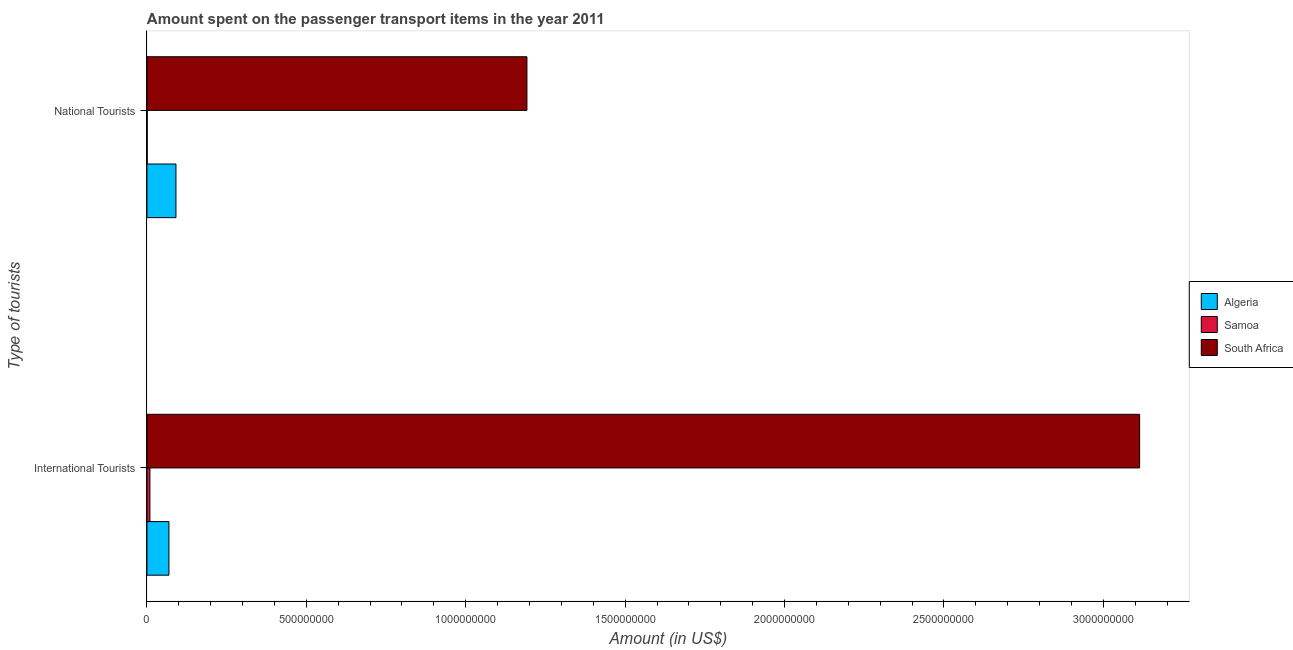How many groups of bars are there?
Your answer should be very brief. 2. How many bars are there on the 2nd tick from the top?
Give a very brief answer. 3. How many bars are there on the 2nd tick from the bottom?
Your answer should be very brief. 3. What is the label of the 2nd group of bars from the top?
Make the answer very short. International Tourists. What is the amount spent on transport items of international tourists in Algeria?
Give a very brief answer. 6.90e+07. Across all countries, what is the maximum amount spent on transport items of international tourists?
Provide a short and direct response. 3.11e+09. Across all countries, what is the minimum amount spent on transport items of national tourists?
Offer a terse response. 9.00e+05. In which country was the amount spent on transport items of international tourists maximum?
Offer a terse response. South Africa. In which country was the amount spent on transport items of national tourists minimum?
Your answer should be very brief. Samoa. What is the total amount spent on transport items of national tourists in the graph?
Your response must be concise. 1.28e+09. What is the difference between the amount spent on transport items of national tourists in South Africa and that in Samoa?
Your response must be concise. 1.19e+09. What is the difference between the amount spent on transport items of national tourists in Samoa and the amount spent on transport items of international tourists in Algeria?
Keep it short and to the point. -6.81e+07. What is the average amount spent on transport items of international tourists per country?
Make the answer very short. 1.06e+09. What is the difference between the amount spent on transport items of national tourists and amount spent on transport items of international tourists in Samoa?
Your answer should be compact. -8.40e+06. What is the ratio of the amount spent on transport items of national tourists in Samoa to that in South Africa?
Your response must be concise. 0. In how many countries, is the amount spent on transport items of international tourists greater than the average amount spent on transport items of international tourists taken over all countries?
Give a very brief answer. 1. What does the 1st bar from the top in International Tourists represents?
Offer a terse response. South Africa. What does the 3rd bar from the bottom in National Tourists represents?
Provide a succinct answer. South Africa. How many countries are there in the graph?
Your response must be concise. 3. What is the difference between two consecutive major ticks on the X-axis?
Offer a very short reply. 5.00e+08. Does the graph contain any zero values?
Provide a short and direct response. No. How many legend labels are there?
Give a very brief answer. 3. What is the title of the graph?
Your response must be concise. Amount spent on the passenger transport items in the year 2011. Does "Congo (Democratic)" appear as one of the legend labels in the graph?
Make the answer very short. No. What is the label or title of the X-axis?
Offer a terse response. Amount (in US$). What is the label or title of the Y-axis?
Your response must be concise. Type of tourists. What is the Amount (in US$) of Algeria in International Tourists?
Keep it short and to the point. 6.90e+07. What is the Amount (in US$) of Samoa in International Tourists?
Provide a short and direct response. 9.30e+06. What is the Amount (in US$) in South Africa in International Tourists?
Make the answer very short. 3.11e+09. What is the Amount (in US$) in Algeria in National Tourists?
Offer a very short reply. 9.10e+07. What is the Amount (in US$) of Samoa in National Tourists?
Ensure brevity in your answer.  9.00e+05. What is the Amount (in US$) of South Africa in National Tourists?
Your answer should be compact. 1.19e+09. Across all Type of tourists, what is the maximum Amount (in US$) in Algeria?
Keep it short and to the point. 9.10e+07. Across all Type of tourists, what is the maximum Amount (in US$) of Samoa?
Provide a succinct answer. 9.30e+06. Across all Type of tourists, what is the maximum Amount (in US$) in South Africa?
Ensure brevity in your answer.  3.11e+09. Across all Type of tourists, what is the minimum Amount (in US$) of Algeria?
Make the answer very short. 6.90e+07. Across all Type of tourists, what is the minimum Amount (in US$) of South Africa?
Keep it short and to the point. 1.19e+09. What is the total Amount (in US$) in Algeria in the graph?
Make the answer very short. 1.60e+08. What is the total Amount (in US$) of Samoa in the graph?
Keep it short and to the point. 1.02e+07. What is the total Amount (in US$) of South Africa in the graph?
Make the answer very short. 4.31e+09. What is the difference between the Amount (in US$) of Algeria in International Tourists and that in National Tourists?
Offer a terse response. -2.20e+07. What is the difference between the Amount (in US$) in Samoa in International Tourists and that in National Tourists?
Provide a succinct answer. 8.40e+06. What is the difference between the Amount (in US$) in South Africa in International Tourists and that in National Tourists?
Keep it short and to the point. 1.92e+09. What is the difference between the Amount (in US$) of Algeria in International Tourists and the Amount (in US$) of Samoa in National Tourists?
Offer a very short reply. 6.81e+07. What is the difference between the Amount (in US$) in Algeria in International Tourists and the Amount (in US$) in South Africa in National Tourists?
Offer a terse response. -1.12e+09. What is the difference between the Amount (in US$) in Samoa in International Tourists and the Amount (in US$) in South Africa in National Tourists?
Offer a terse response. -1.18e+09. What is the average Amount (in US$) of Algeria per Type of tourists?
Your answer should be compact. 8.00e+07. What is the average Amount (in US$) of Samoa per Type of tourists?
Offer a very short reply. 5.10e+06. What is the average Amount (in US$) of South Africa per Type of tourists?
Ensure brevity in your answer.  2.15e+09. What is the difference between the Amount (in US$) in Algeria and Amount (in US$) in Samoa in International Tourists?
Your answer should be very brief. 5.97e+07. What is the difference between the Amount (in US$) of Algeria and Amount (in US$) of South Africa in International Tourists?
Make the answer very short. -3.04e+09. What is the difference between the Amount (in US$) of Samoa and Amount (in US$) of South Africa in International Tourists?
Your answer should be compact. -3.10e+09. What is the difference between the Amount (in US$) of Algeria and Amount (in US$) of Samoa in National Tourists?
Offer a very short reply. 9.01e+07. What is the difference between the Amount (in US$) of Algeria and Amount (in US$) of South Africa in National Tourists?
Offer a terse response. -1.10e+09. What is the difference between the Amount (in US$) of Samoa and Amount (in US$) of South Africa in National Tourists?
Your answer should be very brief. -1.19e+09. What is the ratio of the Amount (in US$) of Algeria in International Tourists to that in National Tourists?
Offer a very short reply. 0.76. What is the ratio of the Amount (in US$) of Samoa in International Tourists to that in National Tourists?
Provide a short and direct response. 10.33. What is the ratio of the Amount (in US$) in South Africa in International Tourists to that in National Tourists?
Provide a short and direct response. 2.61. What is the difference between the highest and the second highest Amount (in US$) in Algeria?
Your answer should be compact. 2.20e+07. What is the difference between the highest and the second highest Amount (in US$) of Samoa?
Provide a succinct answer. 8.40e+06. What is the difference between the highest and the second highest Amount (in US$) in South Africa?
Your answer should be very brief. 1.92e+09. What is the difference between the highest and the lowest Amount (in US$) of Algeria?
Offer a very short reply. 2.20e+07. What is the difference between the highest and the lowest Amount (in US$) in Samoa?
Make the answer very short. 8.40e+06. What is the difference between the highest and the lowest Amount (in US$) in South Africa?
Give a very brief answer. 1.92e+09. 